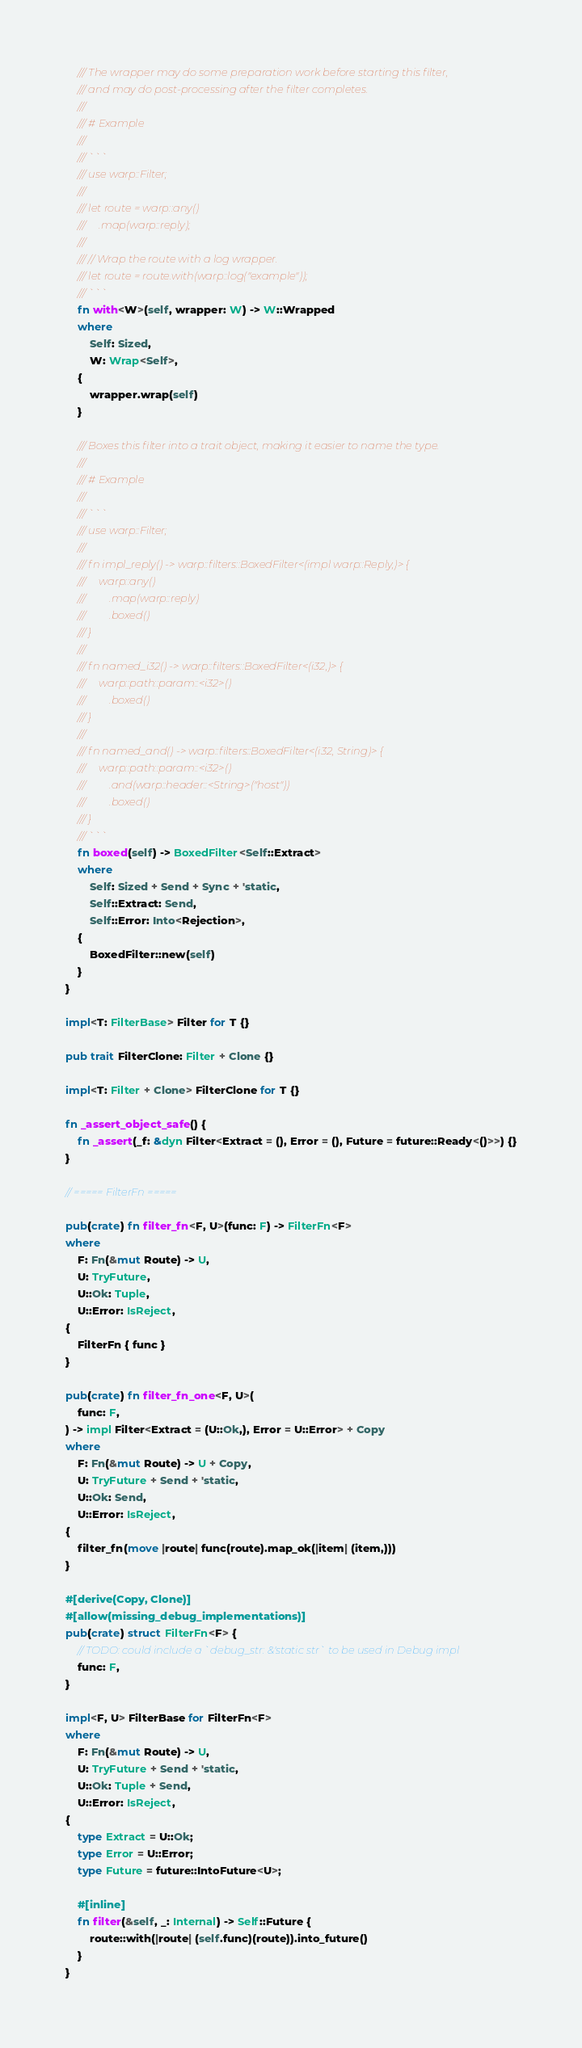Convert code to text. <code><loc_0><loc_0><loc_500><loc_500><_Rust_>    /// The wrapper may do some preparation work before starting this filter,
    /// and may do post-processing after the filter completes.
    ///
    /// # Example
    ///
    /// ```
    /// use warp::Filter;
    ///
    /// let route = warp::any()
    ///     .map(warp::reply);
    ///
    /// // Wrap the route with a log wrapper.
    /// let route = route.with(warp::log("example"));
    /// ```
    fn with<W>(self, wrapper: W) -> W::Wrapped
    where
        Self: Sized,
        W: Wrap<Self>,
    {
        wrapper.wrap(self)
    }

    /// Boxes this filter into a trait object, making it easier to name the type.
    ///
    /// # Example
    ///
    /// ```
    /// use warp::Filter;
    ///
    /// fn impl_reply() -> warp::filters::BoxedFilter<(impl warp::Reply,)> {
    ///     warp::any()
    ///         .map(warp::reply)
    ///         .boxed()
    /// }
    ///
    /// fn named_i32() -> warp::filters::BoxedFilter<(i32,)> {
    ///     warp::path::param::<i32>()
    ///         .boxed()
    /// }
    ///
    /// fn named_and() -> warp::filters::BoxedFilter<(i32, String)> {
    ///     warp::path::param::<i32>()
    ///         .and(warp::header::<String>("host"))
    ///         .boxed()
    /// }
    /// ```
    fn boxed(self) -> BoxedFilter<Self::Extract>
    where
        Self: Sized + Send + Sync + 'static,
        Self::Extract: Send,
        Self::Error: Into<Rejection>,
    {
        BoxedFilter::new(self)
    }
}

impl<T: FilterBase> Filter for T {}

pub trait FilterClone: Filter + Clone {}

impl<T: Filter + Clone> FilterClone for T {}

fn _assert_object_safe() {
    fn _assert(_f: &dyn Filter<Extract = (), Error = (), Future = future::Ready<()>>) {}
}

// ===== FilterFn =====

pub(crate) fn filter_fn<F, U>(func: F) -> FilterFn<F>
where
    F: Fn(&mut Route) -> U,
    U: TryFuture,
    U::Ok: Tuple,
    U::Error: IsReject,
{
    FilterFn { func }
}

pub(crate) fn filter_fn_one<F, U>(
    func: F,
) -> impl Filter<Extract = (U::Ok,), Error = U::Error> + Copy
where
    F: Fn(&mut Route) -> U + Copy,
    U: TryFuture + Send + 'static,
    U::Ok: Send,
    U::Error: IsReject,
{
    filter_fn(move |route| func(route).map_ok(|item| (item,)))
}

#[derive(Copy, Clone)]
#[allow(missing_debug_implementations)]
pub(crate) struct FilterFn<F> {
    // TODO: could include a `debug_str: &'static str` to be used in Debug impl
    func: F,
}

impl<F, U> FilterBase for FilterFn<F>
where
    F: Fn(&mut Route) -> U,
    U: TryFuture + Send + 'static,
    U::Ok: Tuple + Send,
    U::Error: IsReject,
{
    type Extract = U::Ok;
    type Error = U::Error;
    type Future = future::IntoFuture<U>;

    #[inline]
    fn filter(&self, _: Internal) -> Self::Future {
        route::with(|route| (self.func)(route)).into_future()
    }
}
</code> 